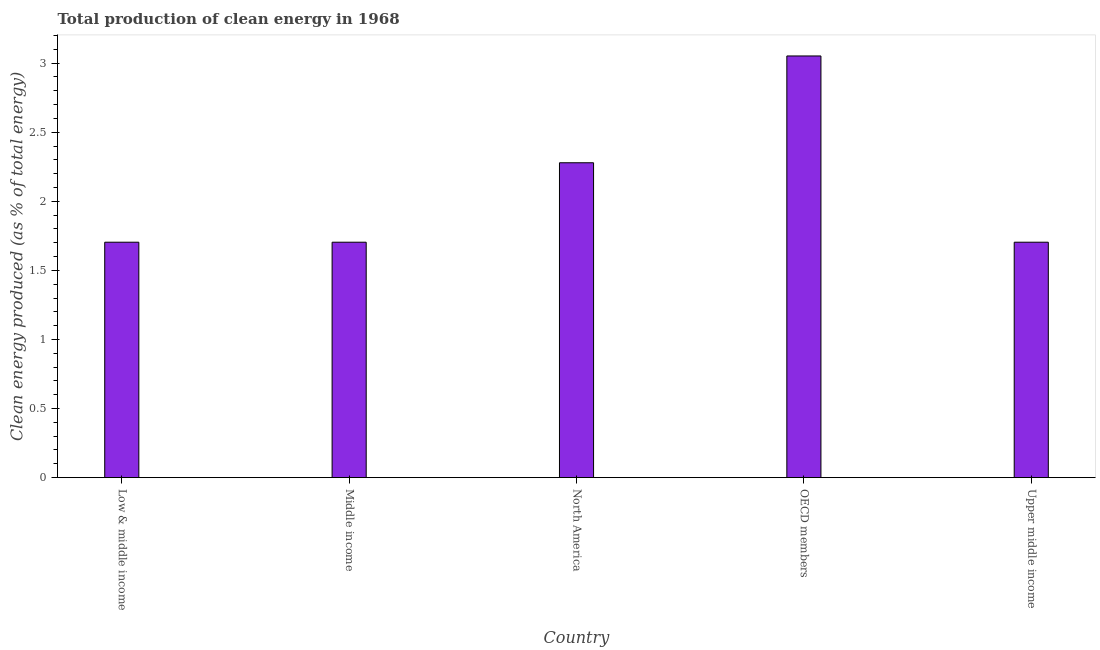Does the graph contain any zero values?
Keep it short and to the point. No. What is the title of the graph?
Ensure brevity in your answer.  Total production of clean energy in 1968. What is the label or title of the Y-axis?
Ensure brevity in your answer.  Clean energy produced (as % of total energy). What is the production of clean energy in Middle income?
Offer a terse response. 1.7. Across all countries, what is the maximum production of clean energy?
Your answer should be compact. 3.05. Across all countries, what is the minimum production of clean energy?
Provide a succinct answer. 1.7. What is the sum of the production of clean energy?
Make the answer very short. 10.44. What is the average production of clean energy per country?
Make the answer very short. 2.09. What is the median production of clean energy?
Make the answer very short. 1.7. Is the difference between the production of clean energy in Middle income and OECD members greater than the difference between any two countries?
Your answer should be very brief. Yes. What is the difference between the highest and the second highest production of clean energy?
Your answer should be very brief. 0.77. What is the difference between the highest and the lowest production of clean energy?
Make the answer very short. 1.35. In how many countries, is the production of clean energy greater than the average production of clean energy taken over all countries?
Keep it short and to the point. 2. How many bars are there?
Give a very brief answer. 5. How many countries are there in the graph?
Provide a succinct answer. 5. What is the difference between two consecutive major ticks on the Y-axis?
Your response must be concise. 0.5. Are the values on the major ticks of Y-axis written in scientific E-notation?
Make the answer very short. No. What is the Clean energy produced (as % of total energy) of Low & middle income?
Make the answer very short. 1.7. What is the Clean energy produced (as % of total energy) of Middle income?
Your answer should be compact. 1.7. What is the Clean energy produced (as % of total energy) in North America?
Your answer should be compact. 2.28. What is the Clean energy produced (as % of total energy) of OECD members?
Your response must be concise. 3.05. What is the Clean energy produced (as % of total energy) in Upper middle income?
Your response must be concise. 1.7. What is the difference between the Clean energy produced (as % of total energy) in Low & middle income and North America?
Ensure brevity in your answer.  -0.57. What is the difference between the Clean energy produced (as % of total energy) in Low & middle income and OECD members?
Give a very brief answer. -1.35. What is the difference between the Clean energy produced (as % of total energy) in Middle income and North America?
Offer a very short reply. -0.57. What is the difference between the Clean energy produced (as % of total energy) in Middle income and OECD members?
Make the answer very short. -1.35. What is the difference between the Clean energy produced (as % of total energy) in North America and OECD members?
Offer a terse response. -0.77. What is the difference between the Clean energy produced (as % of total energy) in North America and Upper middle income?
Make the answer very short. 0.57. What is the difference between the Clean energy produced (as % of total energy) in OECD members and Upper middle income?
Your answer should be very brief. 1.35. What is the ratio of the Clean energy produced (as % of total energy) in Low & middle income to that in North America?
Provide a succinct answer. 0.75. What is the ratio of the Clean energy produced (as % of total energy) in Low & middle income to that in OECD members?
Offer a very short reply. 0.56. What is the ratio of the Clean energy produced (as % of total energy) in Low & middle income to that in Upper middle income?
Keep it short and to the point. 1. What is the ratio of the Clean energy produced (as % of total energy) in Middle income to that in North America?
Keep it short and to the point. 0.75. What is the ratio of the Clean energy produced (as % of total energy) in Middle income to that in OECD members?
Keep it short and to the point. 0.56. What is the ratio of the Clean energy produced (as % of total energy) in North America to that in OECD members?
Provide a short and direct response. 0.75. What is the ratio of the Clean energy produced (as % of total energy) in North America to that in Upper middle income?
Make the answer very short. 1.34. What is the ratio of the Clean energy produced (as % of total energy) in OECD members to that in Upper middle income?
Keep it short and to the point. 1.79. 